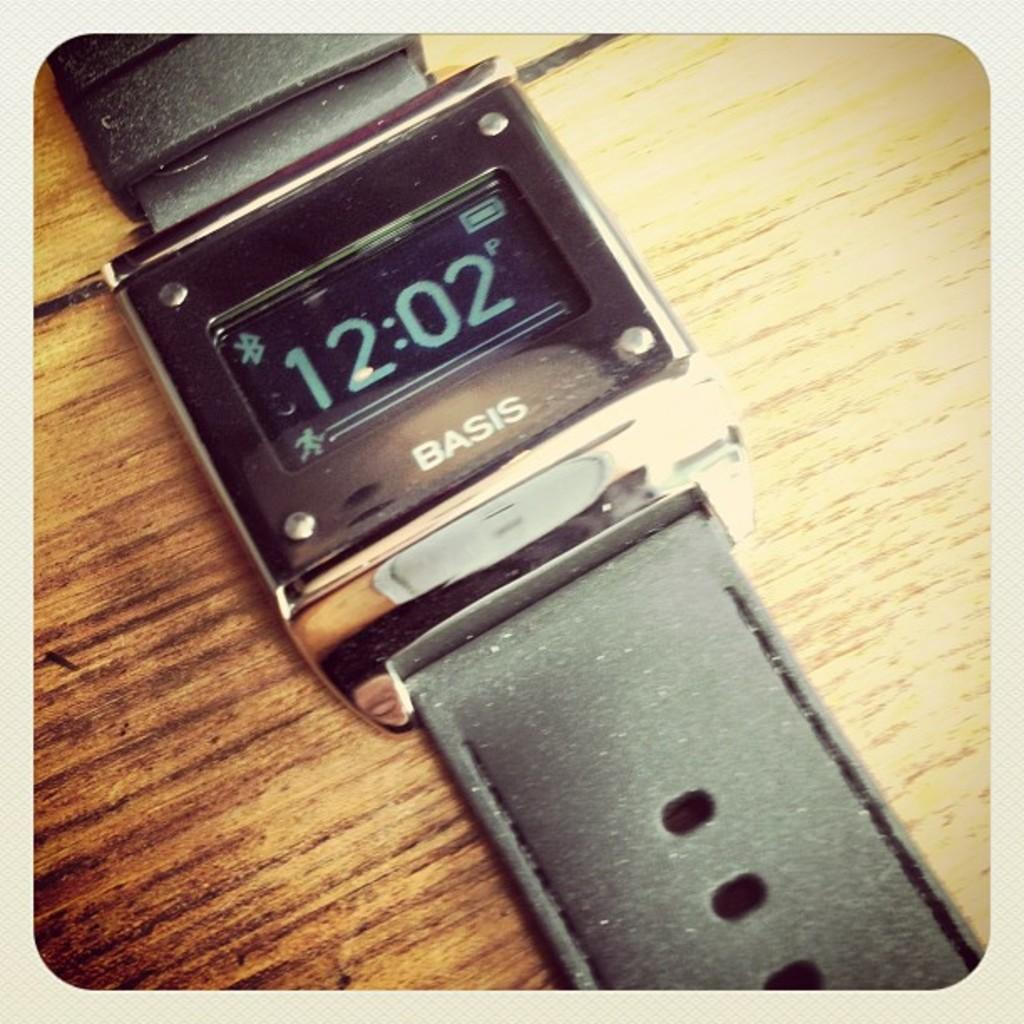<image>
Give a short and clear explanation of the subsequent image. A black Basis watch with a display showing 12:02 pm. 